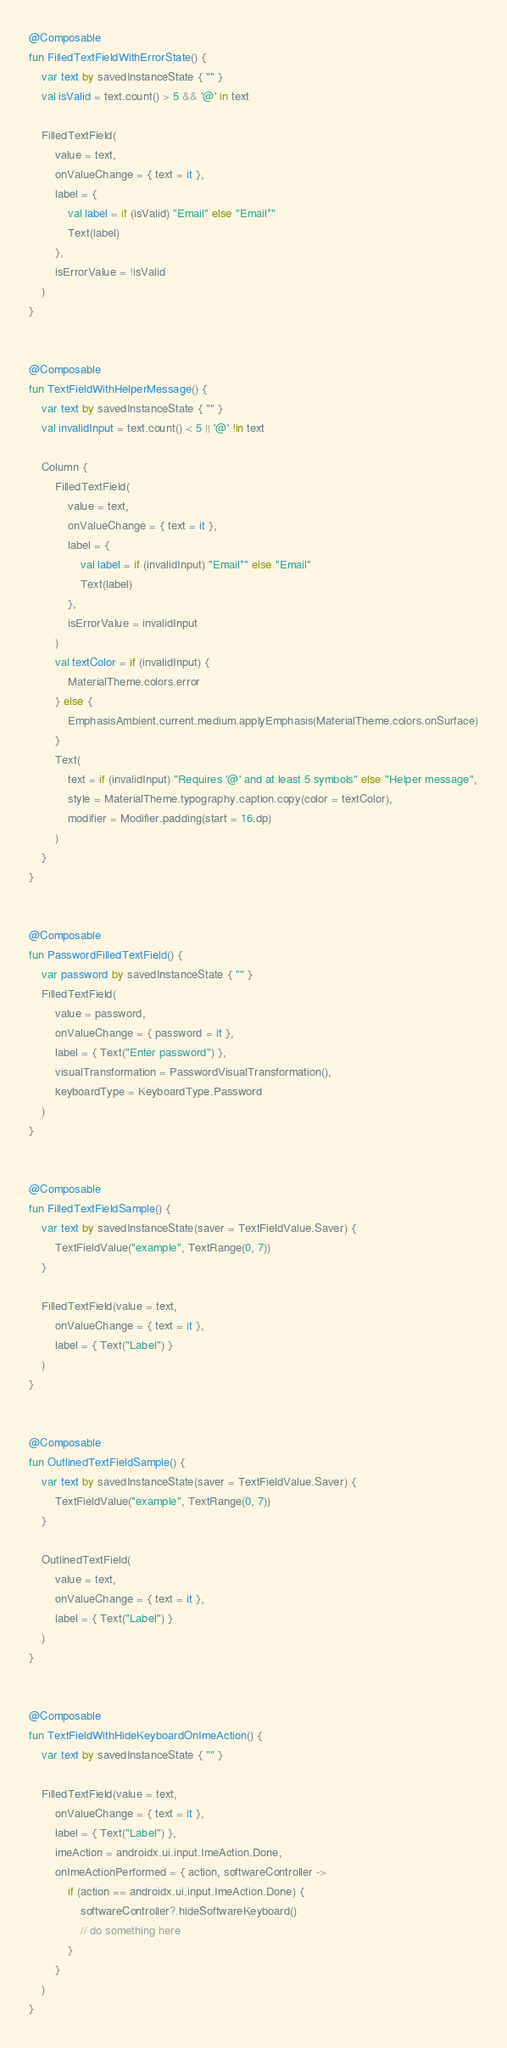<code> <loc_0><loc_0><loc_500><loc_500><_Kotlin_>

@Composable
fun FilledTextFieldWithErrorState() {
    var text by savedInstanceState { "" }
    val isValid = text.count() > 5 && '@' in text

    FilledTextField(
        value = text,
        onValueChange = { text = it },
        label = {
            val label = if (isValid) "Email" else "Email*"
            Text(label)
        },
        isErrorValue = !isValid
    )
}


@Composable
fun TextFieldWithHelperMessage() {
    var text by savedInstanceState { "" }
    val invalidInput = text.count() < 5 || '@' !in text

    Column {
        FilledTextField(
            value = text,
            onValueChange = { text = it },
            label = {
                val label = if (invalidInput) "Email*" else "Email"
                Text(label)
            },
            isErrorValue = invalidInput
        )
        val textColor = if (invalidInput) {
            MaterialTheme.colors.error
        } else {
            EmphasisAmbient.current.medium.applyEmphasis(MaterialTheme.colors.onSurface)
        }
        Text(
            text = if (invalidInput) "Requires '@' and at least 5 symbols" else "Helper message",
            style = MaterialTheme.typography.caption.copy(color = textColor),
            modifier = Modifier.padding(start = 16.dp)
        )
    }
}


@Composable
fun PasswordFilledTextField() {
    var password by savedInstanceState { "" }
    FilledTextField(
        value = password,
        onValueChange = { password = it },
        label = { Text("Enter password") },
        visualTransformation = PasswordVisualTransformation(),
        keyboardType = KeyboardType.Password
    )
}


@Composable
fun FilledTextFieldSample() {
    var text by savedInstanceState(saver = TextFieldValue.Saver) {
        TextFieldValue("example", TextRange(0, 7))
    }

    FilledTextField(value = text,
        onValueChange = { text = it },
        label = { Text("Label") }
    )
}


@Composable
fun OutlinedTextFieldSample() {
    var text by savedInstanceState(saver = TextFieldValue.Saver) {
        TextFieldValue("example", TextRange(0, 7))
    }

    OutlinedTextField(
        value = text,
        onValueChange = { text = it },
        label = { Text("Label") }
    )
}


@Composable
fun TextFieldWithHideKeyboardOnImeAction() {
    var text by savedInstanceState { "" }

    FilledTextField(value = text,
        onValueChange = { text = it },
        label = { Text("Label") },
        imeAction = androidx.ui.input.ImeAction.Done,
        onImeActionPerformed = { action, softwareController ->
            if (action == androidx.ui.input.ImeAction.Done) {
                softwareController?.hideSoftwareKeyboard()
                // do something here
            }
        }
    )
}</code> 